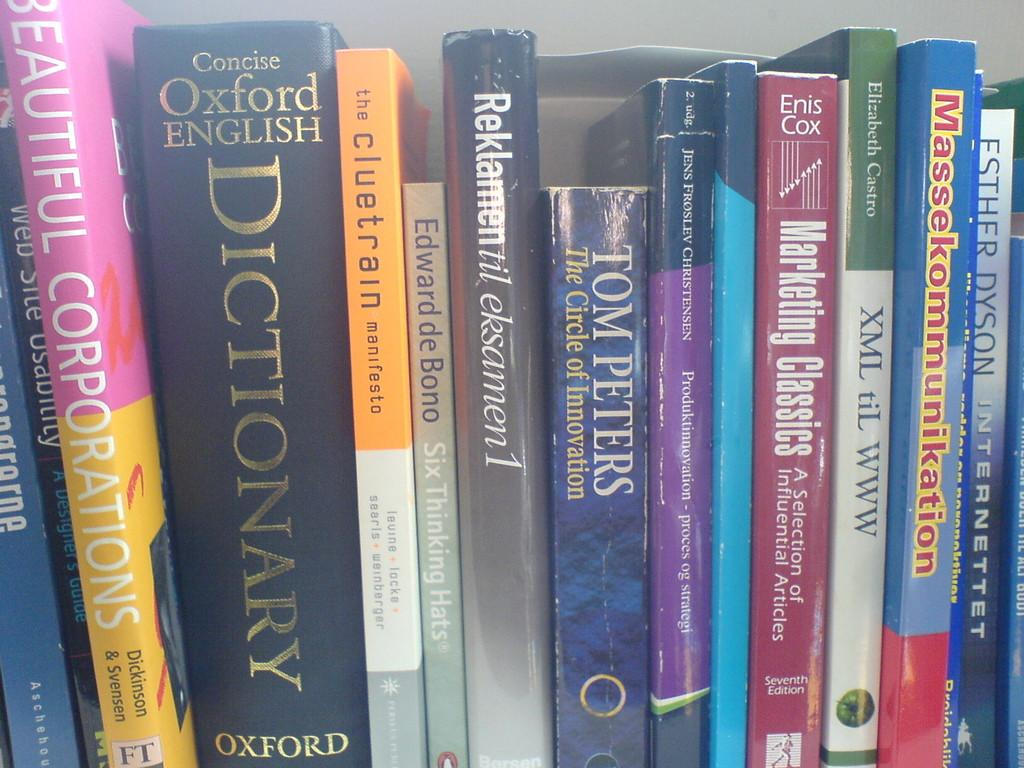<image>
Render a clear and concise summary of the photo. a section of books with a dictionary included in the mi 